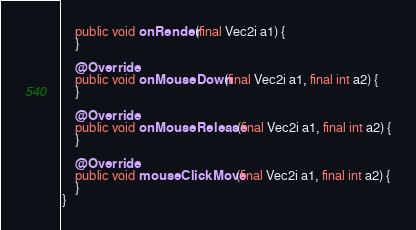<code> <loc_0><loc_0><loc_500><loc_500><_Java_>    public void onRender(final Vec2i a1) {
    }
    
    @Override
    public void onMouseDown(final Vec2i a1, final int a2) {
    }
    
    @Override
    public void onMouseRelease(final Vec2i a1, final int a2) {
    }
    
    @Override
    public void mouseClickMove(final Vec2i a1, final int a2) {
    }
}
</code> 